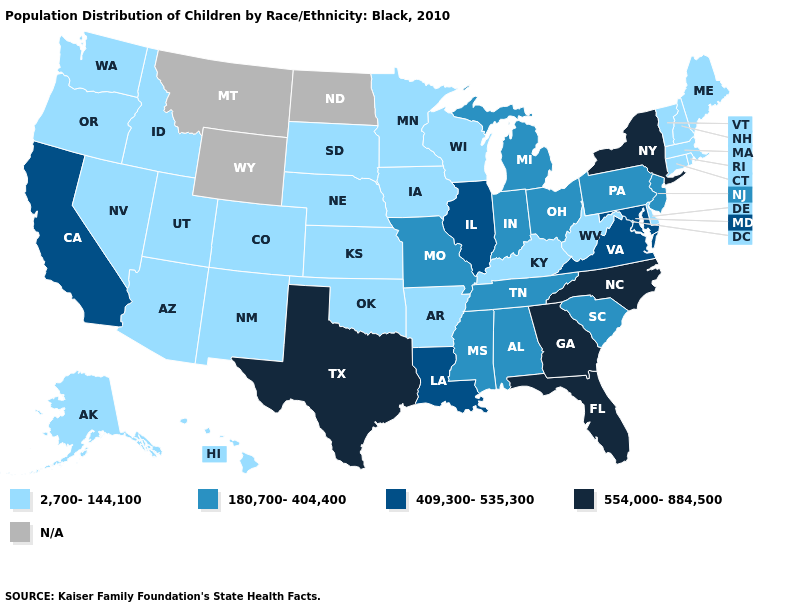What is the highest value in states that border Wyoming?
Short answer required. 2,700-144,100. Which states have the lowest value in the USA?
Write a very short answer. Alaska, Arizona, Arkansas, Colorado, Connecticut, Delaware, Hawaii, Idaho, Iowa, Kansas, Kentucky, Maine, Massachusetts, Minnesota, Nebraska, Nevada, New Hampshire, New Mexico, Oklahoma, Oregon, Rhode Island, South Dakota, Utah, Vermont, Washington, West Virginia, Wisconsin. What is the value of Iowa?
Concise answer only. 2,700-144,100. Among the states that border Kentucky , does Tennessee have the highest value?
Short answer required. No. Which states have the lowest value in the USA?
Concise answer only. Alaska, Arizona, Arkansas, Colorado, Connecticut, Delaware, Hawaii, Idaho, Iowa, Kansas, Kentucky, Maine, Massachusetts, Minnesota, Nebraska, Nevada, New Hampshire, New Mexico, Oklahoma, Oregon, Rhode Island, South Dakota, Utah, Vermont, Washington, West Virginia, Wisconsin. Name the states that have a value in the range 409,300-535,300?
Quick response, please. California, Illinois, Louisiana, Maryland, Virginia. Which states hav the highest value in the South?
Write a very short answer. Florida, Georgia, North Carolina, Texas. Is the legend a continuous bar?
Concise answer only. No. Is the legend a continuous bar?
Write a very short answer. No. Does Utah have the lowest value in the USA?
Write a very short answer. Yes. What is the value of Arkansas?
Short answer required. 2,700-144,100. What is the value of Montana?
Keep it brief. N/A. What is the value of Minnesota?
Keep it brief. 2,700-144,100. What is the highest value in the South ?
Be succinct. 554,000-884,500. 